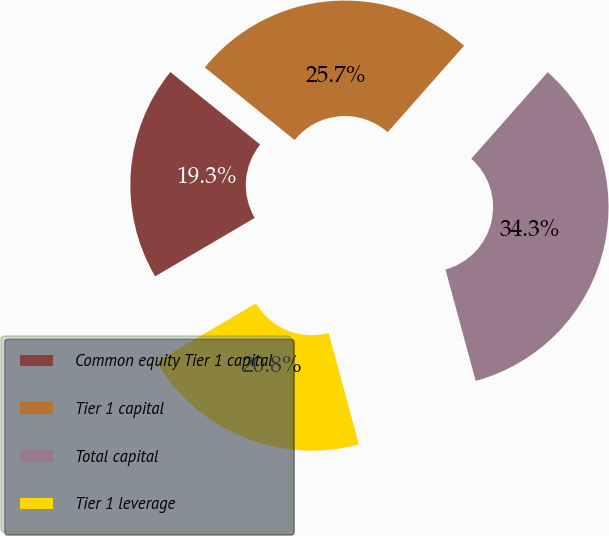Convert chart. <chart><loc_0><loc_0><loc_500><loc_500><pie_chart><fcel>Common equity Tier 1 capital<fcel>Tier 1 capital<fcel>Total capital<fcel>Tier 1 leverage<nl><fcel>19.27%<fcel>25.7%<fcel>34.26%<fcel>20.77%<nl></chart> 